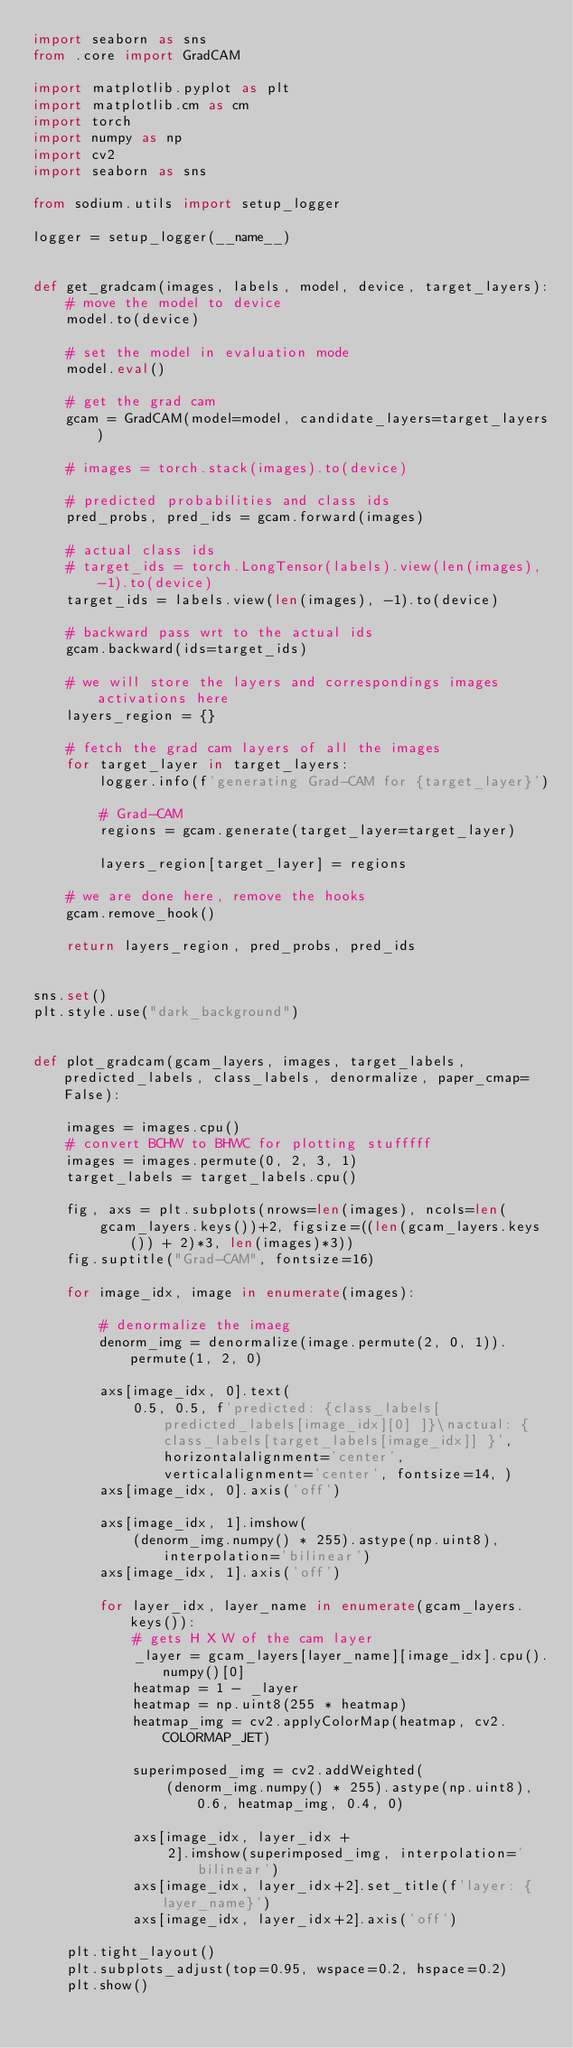Convert code to text. <code><loc_0><loc_0><loc_500><loc_500><_Python_>import seaborn as sns
from .core import GradCAM

import matplotlib.pyplot as plt
import matplotlib.cm as cm
import torch
import numpy as np
import cv2
import seaborn as sns

from sodium.utils import setup_logger

logger = setup_logger(__name__)


def get_gradcam(images, labels, model, device, target_layers):
    # move the model to device
    model.to(device)

    # set the model in evaluation mode
    model.eval()

    # get the grad cam
    gcam = GradCAM(model=model, candidate_layers=target_layers)

    # images = torch.stack(images).to(device)

    # predicted probabilities and class ids
    pred_probs, pred_ids = gcam.forward(images)

    # actual class ids
    # target_ids = torch.LongTensor(labels).view(len(images), -1).to(device)
    target_ids = labels.view(len(images), -1).to(device)

    # backward pass wrt to the actual ids
    gcam.backward(ids=target_ids)

    # we will store the layers and correspondings images activations here
    layers_region = {}

    # fetch the grad cam layers of all the images
    for target_layer in target_layers:
        logger.info(f'generating Grad-CAM for {target_layer}')

        # Grad-CAM
        regions = gcam.generate(target_layer=target_layer)

        layers_region[target_layer] = regions

    # we are done here, remove the hooks
    gcam.remove_hook()

    return layers_region, pred_probs, pred_ids


sns.set()
plt.style.use("dark_background")


def plot_gradcam(gcam_layers, images, target_labels, predicted_labels, class_labels, denormalize, paper_cmap=False):

    images = images.cpu()
    # convert BCHW to BHWC for plotting stufffff
    images = images.permute(0, 2, 3, 1)
    target_labels = target_labels.cpu()

    fig, axs = plt.subplots(nrows=len(images), ncols=len(
        gcam_layers.keys())+2, figsize=((len(gcam_layers.keys()) + 2)*3, len(images)*3))
    fig.suptitle("Grad-CAM", fontsize=16)

    for image_idx, image in enumerate(images):

        # denormalize the imaeg
        denorm_img = denormalize(image.permute(2, 0, 1)).permute(1, 2, 0)

        axs[image_idx, 0].text(
            0.5, 0.5, f'predicted: {class_labels[predicted_labels[image_idx][0] ]}\nactual: {class_labels[target_labels[image_idx]] }', horizontalalignment='center', verticalalignment='center', fontsize=14, )
        axs[image_idx, 0].axis('off')

        axs[image_idx, 1].imshow(
            (denorm_img.numpy() * 255).astype(np.uint8),  interpolation='bilinear')
        axs[image_idx, 1].axis('off')

        for layer_idx, layer_name in enumerate(gcam_layers.keys()):
            # gets H X W of the cam layer
            _layer = gcam_layers[layer_name][image_idx].cpu().numpy()[0]
            heatmap = 1 - _layer
            heatmap = np.uint8(255 * heatmap)
            heatmap_img = cv2.applyColorMap(heatmap, cv2.COLORMAP_JET)

            superimposed_img = cv2.addWeighted(
                (denorm_img.numpy() * 255).astype(np.uint8), 0.6, heatmap_img, 0.4, 0)

            axs[image_idx, layer_idx +
                2].imshow(superimposed_img, interpolation='bilinear')
            axs[image_idx, layer_idx+2].set_title(f'layer: {layer_name}')
            axs[image_idx, layer_idx+2].axis('off')

    plt.tight_layout()
    plt.subplots_adjust(top=0.95, wspace=0.2, hspace=0.2)
    plt.show()
</code> 